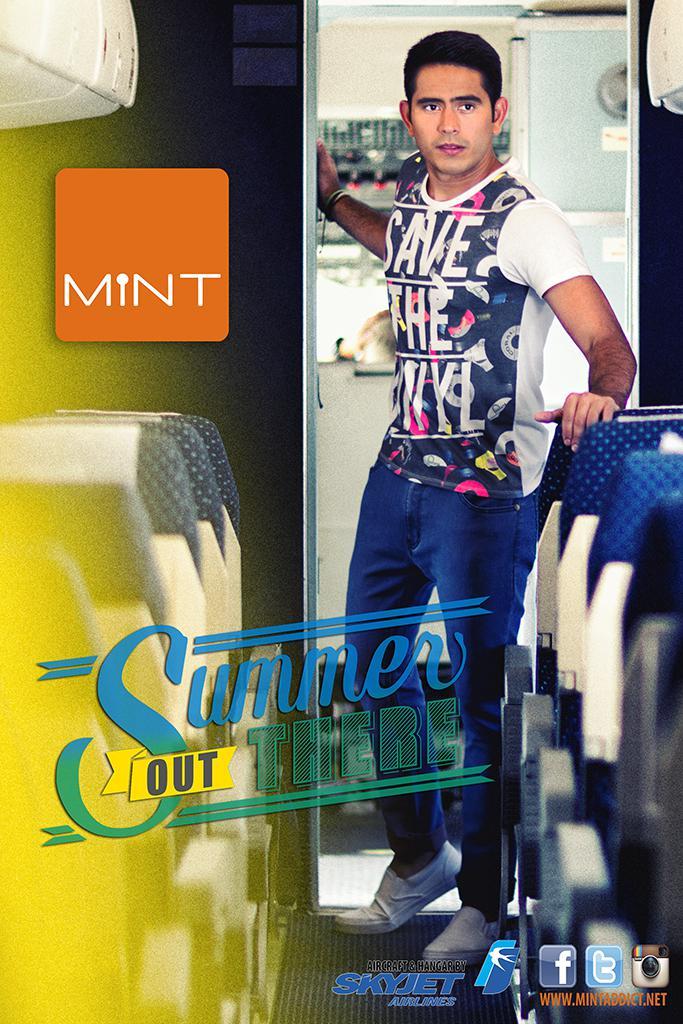What is the title of the poster?
Give a very brief answer. Summer out there. 